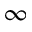Convert formula to latex. <formula><loc_0><loc_0><loc_500><loc_500>\infty</formula> 